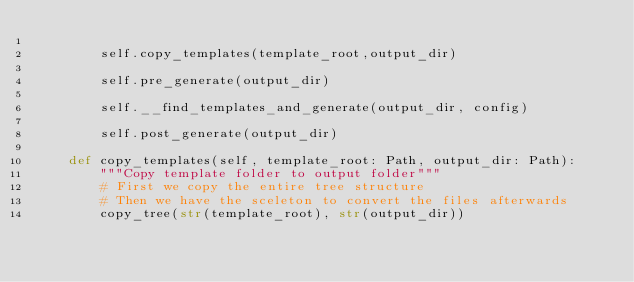<code> <loc_0><loc_0><loc_500><loc_500><_Python_>
        self.copy_templates(template_root,output_dir)

        self.pre_generate(output_dir)

        self.__find_templates_and_generate(output_dir, config)

        self.post_generate(output_dir)

    def copy_templates(self, template_root: Path, output_dir: Path):
        """Copy template folder to output folder"""
        # First we copy the entire tree structure
        # Then we have the sceleton to convert the files afterwards
        copy_tree(str(template_root), str(output_dir))
</code> 